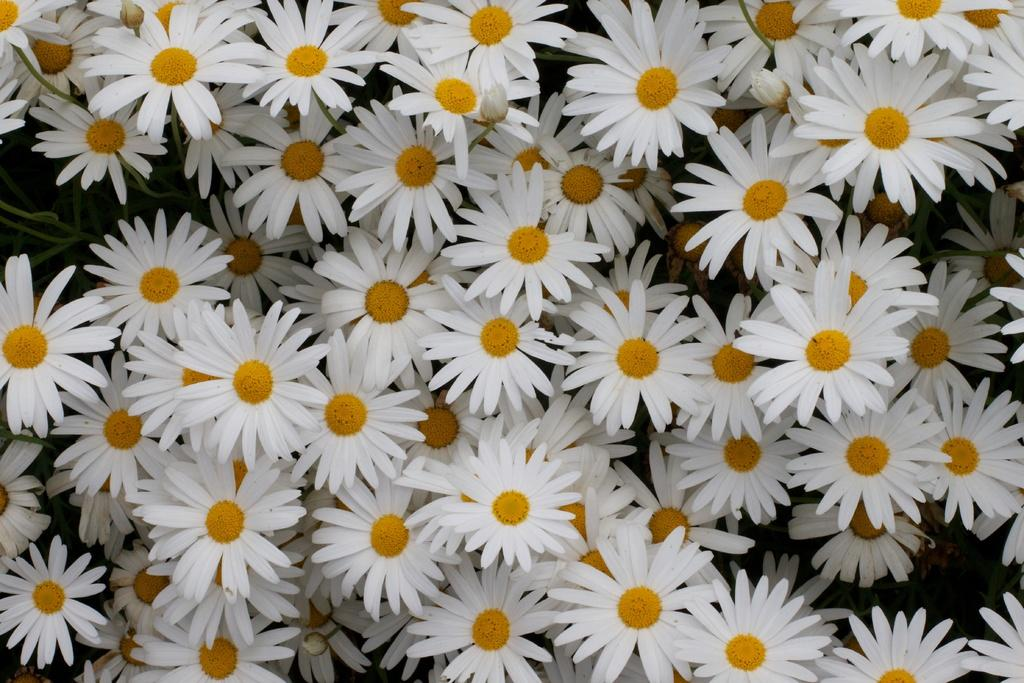What is the main subject of the picture? The main subject of the picture is a bunch of flowers. What colors can be seen in the bunch of flowers? The flowers are white and yellow in color. How many times does the hand sneeze in the image? There is no hand or sneezing present in the image; it features a bunch of flowers. 